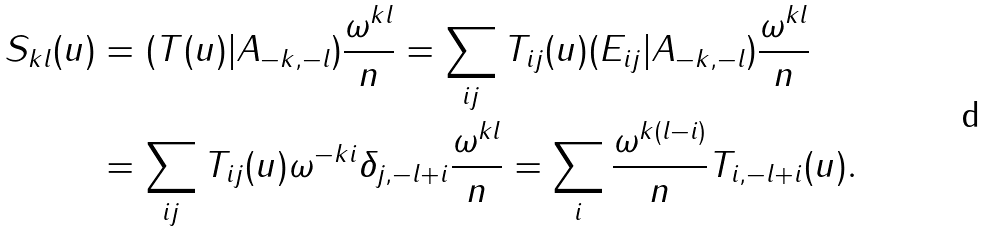Convert formula to latex. <formula><loc_0><loc_0><loc_500><loc_500>S _ { k l } ( u ) & = ( T ( u ) | A _ { - k , - l } ) \frac { \omega ^ { k l } } n = \sum _ { i j } T _ { i j } ( u ) ( E _ { i j } | A _ { - k , - l } ) \frac { \omega ^ { k l } } n \\ & = \sum _ { i j } T _ { i j } ( u ) \omega ^ { - k i } \delta _ { j , - l + i } \frac { \omega ^ { k l } } n = \sum _ { i } \frac { \omega ^ { k ( l - i ) } } n T _ { i , - l + i } ( u ) .</formula> 